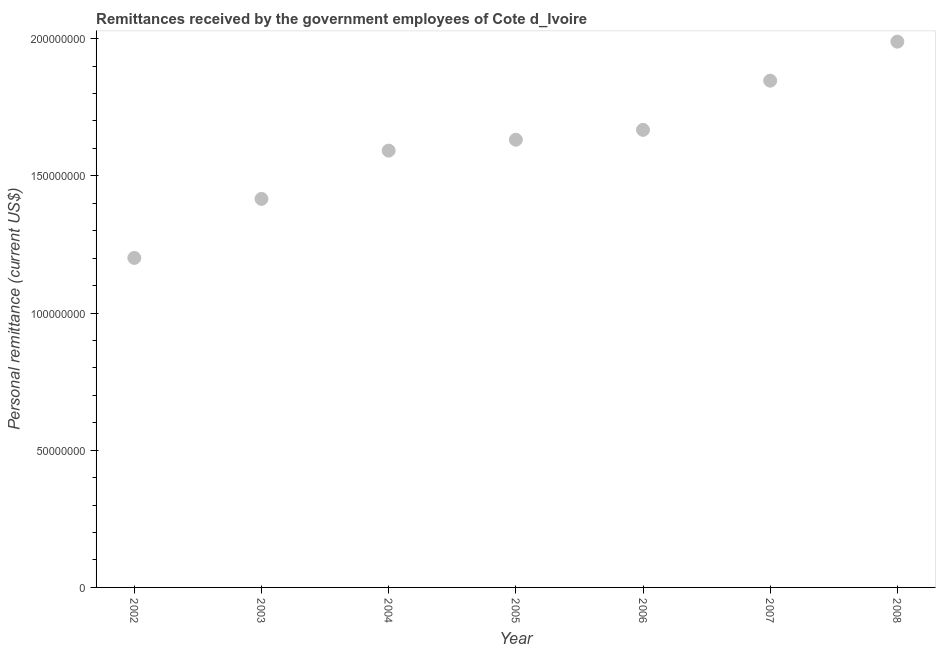What is the personal remittances in 2006?
Make the answer very short. 1.67e+08. Across all years, what is the maximum personal remittances?
Your answer should be compact. 1.99e+08. Across all years, what is the minimum personal remittances?
Make the answer very short. 1.20e+08. In which year was the personal remittances maximum?
Your response must be concise. 2008. What is the sum of the personal remittances?
Your answer should be very brief. 1.13e+09. What is the difference between the personal remittances in 2007 and 2008?
Your response must be concise. -1.42e+07. What is the average personal remittances per year?
Ensure brevity in your answer.  1.62e+08. What is the median personal remittances?
Give a very brief answer. 1.63e+08. In how many years, is the personal remittances greater than 190000000 US$?
Offer a very short reply. 1. What is the ratio of the personal remittances in 2004 to that in 2006?
Provide a succinct answer. 0.95. What is the difference between the highest and the second highest personal remittances?
Your response must be concise. 1.42e+07. Is the sum of the personal remittances in 2002 and 2006 greater than the maximum personal remittances across all years?
Your answer should be compact. Yes. What is the difference between the highest and the lowest personal remittances?
Offer a very short reply. 7.88e+07. How many dotlines are there?
Make the answer very short. 1. Are the values on the major ticks of Y-axis written in scientific E-notation?
Make the answer very short. No. Does the graph contain any zero values?
Provide a short and direct response. No. What is the title of the graph?
Make the answer very short. Remittances received by the government employees of Cote d_Ivoire. What is the label or title of the X-axis?
Offer a very short reply. Year. What is the label or title of the Y-axis?
Your answer should be compact. Personal remittance (current US$). What is the Personal remittance (current US$) in 2002?
Give a very brief answer. 1.20e+08. What is the Personal remittance (current US$) in 2003?
Keep it short and to the point. 1.42e+08. What is the Personal remittance (current US$) in 2004?
Keep it short and to the point. 1.59e+08. What is the Personal remittance (current US$) in 2005?
Your answer should be very brief. 1.63e+08. What is the Personal remittance (current US$) in 2006?
Ensure brevity in your answer.  1.67e+08. What is the Personal remittance (current US$) in 2007?
Your answer should be compact. 1.85e+08. What is the Personal remittance (current US$) in 2008?
Your answer should be compact. 1.99e+08. What is the difference between the Personal remittance (current US$) in 2002 and 2003?
Your answer should be compact. -2.15e+07. What is the difference between the Personal remittance (current US$) in 2002 and 2004?
Make the answer very short. -3.91e+07. What is the difference between the Personal remittance (current US$) in 2002 and 2005?
Make the answer very short. -4.31e+07. What is the difference between the Personal remittance (current US$) in 2002 and 2006?
Your answer should be very brief. -4.67e+07. What is the difference between the Personal remittance (current US$) in 2002 and 2007?
Your answer should be very brief. -6.46e+07. What is the difference between the Personal remittance (current US$) in 2002 and 2008?
Give a very brief answer. -7.88e+07. What is the difference between the Personal remittance (current US$) in 2003 and 2004?
Your answer should be compact. -1.76e+07. What is the difference between the Personal remittance (current US$) in 2003 and 2005?
Provide a short and direct response. -2.16e+07. What is the difference between the Personal remittance (current US$) in 2003 and 2006?
Your answer should be compact. -2.52e+07. What is the difference between the Personal remittance (current US$) in 2003 and 2007?
Provide a succinct answer. -4.31e+07. What is the difference between the Personal remittance (current US$) in 2003 and 2008?
Your answer should be compact. -5.73e+07. What is the difference between the Personal remittance (current US$) in 2004 and 2005?
Give a very brief answer. -3.98e+06. What is the difference between the Personal remittance (current US$) in 2004 and 2006?
Keep it short and to the point. -7.56e+06. What is the difference between the Personal remittance (current US$) in 2004 and 2007?
Offer a very short reply. -2.55e+07. What is the difference between the Personal remittance (current US$) in 2004 and 2008?
Ensure brevity in your answer.  -3.97e+07. What is the difference between the Personal remittance (current US$) in 2005 and 2006?
Your answer should be compact. -3.59e+06. What is the difference between the Personal remittance (current US$) in 2005 and 2007?
Provide a succinct answer. -2.15e+07. What is the difference between the Personal remittance (current US$) in 2005 and 2008?
Ensure brevity in your answer.  -3.57e+07. What is the difference between the Personal remittance (current US$) in 2006 and 2007?
Your answer should be compact. -1.79e+07. What is the difference between the Personal remittance (current US$) in 2006 and 2008?
Give a very brief answer. -3.22e+07. What is the difference between the Personal remittance (current US$) in 2007 and 2008?
Keep it short and to the point. -1.42e+07. What is the ratio of the Personal remittance (current US$) in 2002 to that in 2003?
Your answer should be very brief. 0.85. What is the ratio of the Personal remittance (current US$) in 2002 to that in 2004?
Your answer should be compact. 0.75. What is the ratio of the Personal remittance (current US$) in 2002 to that in 2005?
Offer a very short reply. 0.74. What is the ratio of the Personal remittance (current US$) in 2002 to that in 2006?
Your answer should be compact. 0.72. What is the ratio of the Personal remittance (current US$) in 2002 to that in 2007?
Keep it short and to the point. 0.65. What is the ratio of the Personal remittance (current US$) in 2002 to that in 2008?
Offer a very short reply. 0.6. What is the ratio of the Personal remittance (current US$) in 2003 to that in 2004?
Offer a terse response. 0.89. What is the ratio of the Personal remittance (current US$) in 2003 to that in 2005?
Your answer should be compact. 0.87. What is the ratio of the Personal remittance (current US$) in 2003 to that in 2006?
Give a very brief answer. 0.85. What is the ratio of the Personal remittance (current US$) in 2003 to that in 2007?
Give a very brief answer. 0.77. What is the ratio of the Personal remittance (current US$) in 2003 to that in 2008?
Provide a succinct answer. 0.71. What is the ratio of the Personal remittance (current US$) in 2004 to that in 2005?
Give a very brief answer. 0.98. What is the ratio of the Personal remittance (current US$) in 2004 to that in 2006?
Give a very brief answer. 0.95. What is the ratio of the Personal remittance (current US$) in 2004 to that in 2007?
Ensure brevity in your answer.  0.86. What is the ratio of the Personal remittance (current US$) in 2004 to that in 2008?
Keep it short and to the point. 0.8. What is the ratio of the Personal remittance (current US$) in 2005 to that in 2007?
Offer a terse response. 0.88. What is the ratio of the Personal remittance (current US$) in 2005 to that in 2008?
Give a very brief answer. 0.82. What is the ratio of the Personal remittance (current US$) in 2006 to that in 2007?
Your answer should be compact. 0.9. What is the ratio of the Personal remittance (current US$) in 2006 to that in 2008?
Keep it short and to the point. 0.84. What is the ratio of the Personal remittance (current US$) in 2007 to that in 2008?
Your response must be concise. 0.93. 